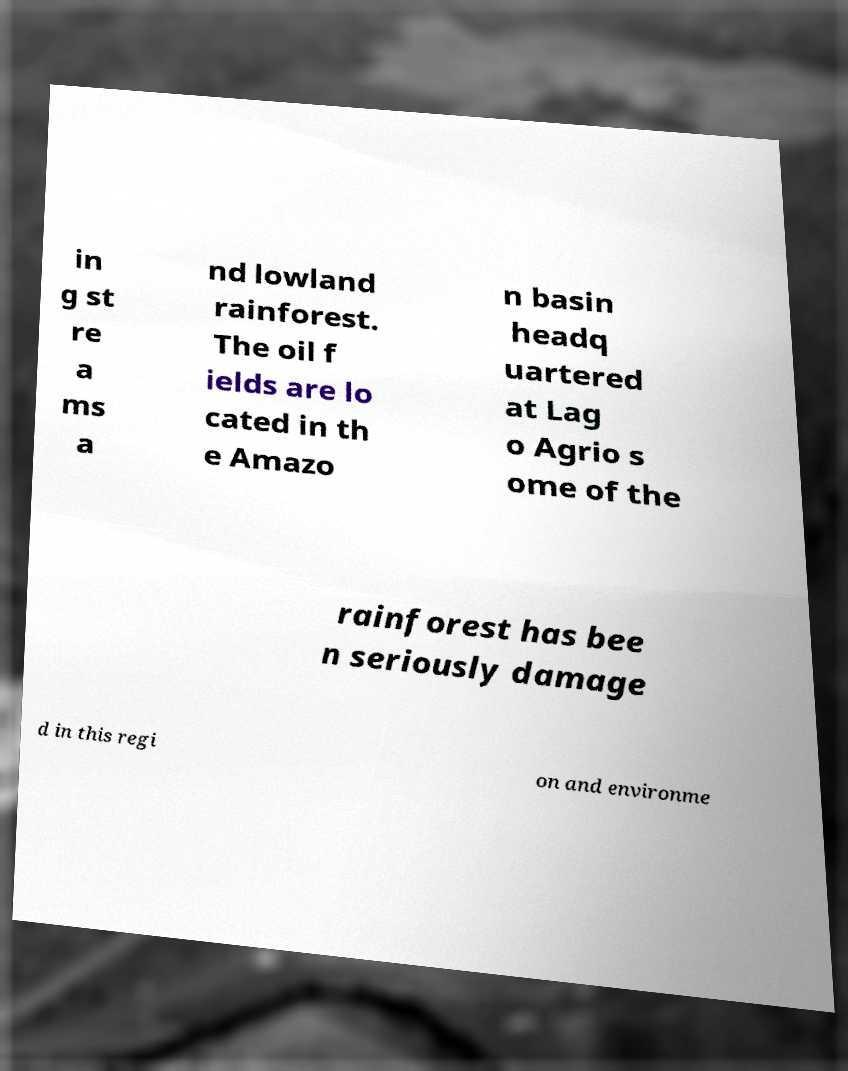Could you extract and type out the text from this image? in g st re a ms a nd lowland rainforest. The oil f ields are lo cated in th e Amazo n basin headq uartered at Lag o Agrio s ome of the rainforest has bee n seriously damage d in this regi on and environme 